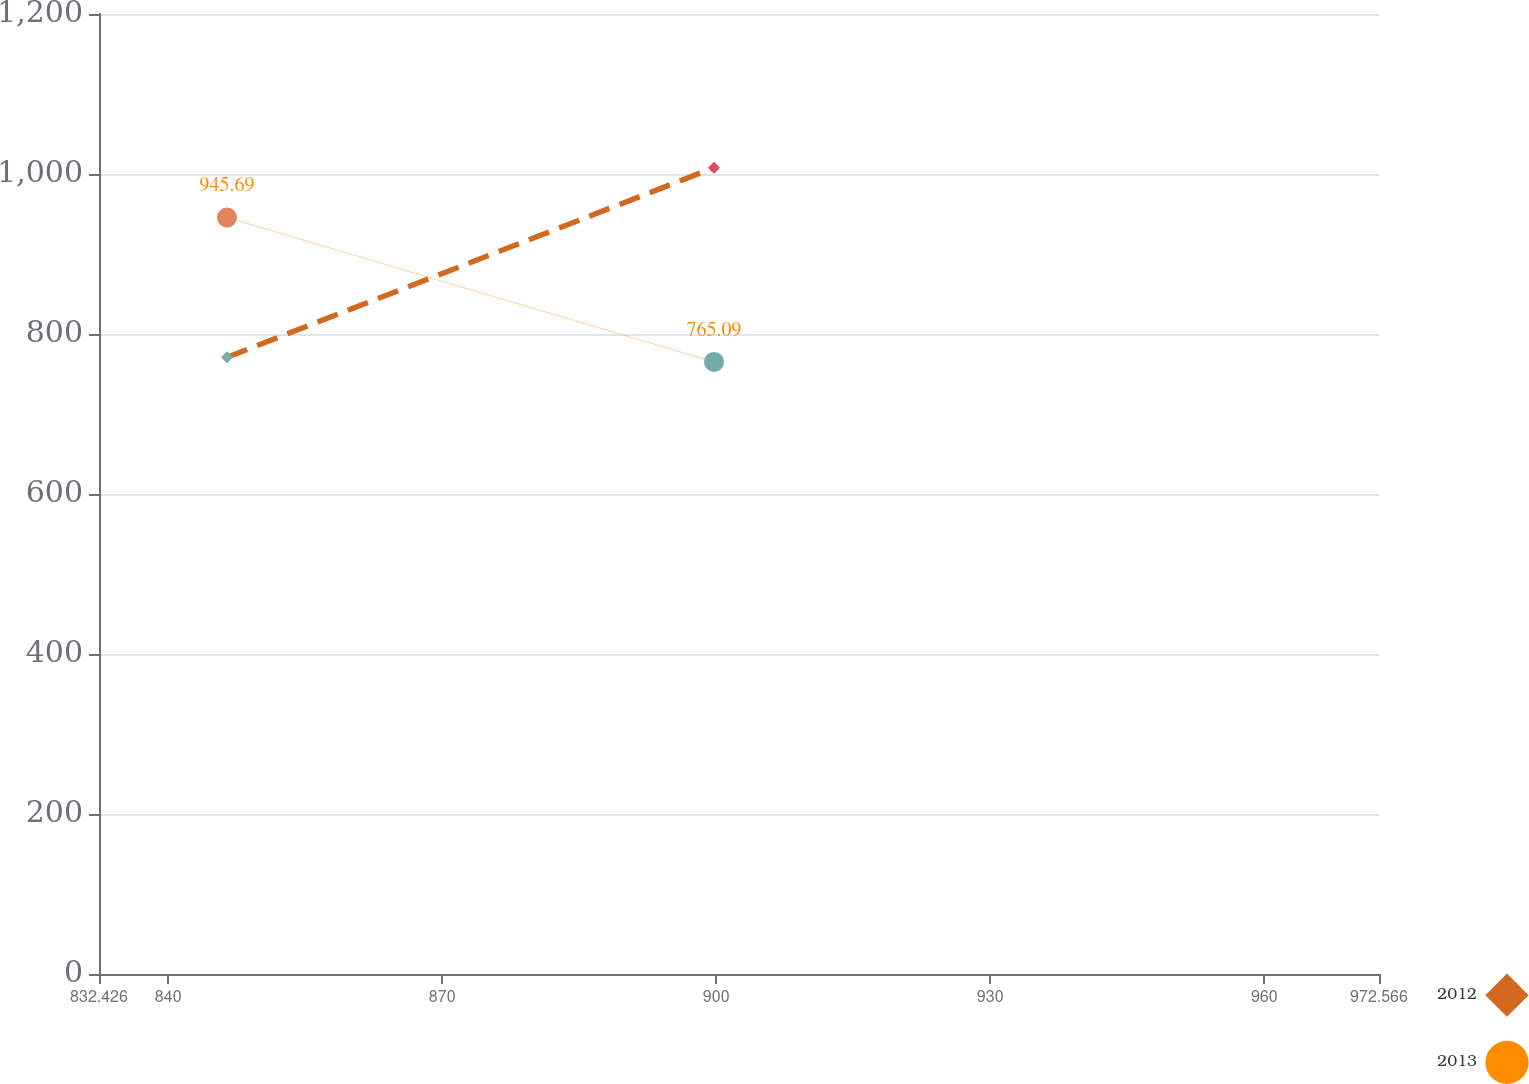Convert chart. <chart><loc_0><loc_0><loc_500><loc_500><line_chart><ecel><fcel>2012<fcel>2013<nl><fcel>846.44<fcel>770.84<fcel>945.69<nl><fcel>899.76<fcel>1007.93<fcel>765.09<nl><fcel>986.58<fcel>884.24<fcel>735.33<nl></chart> 